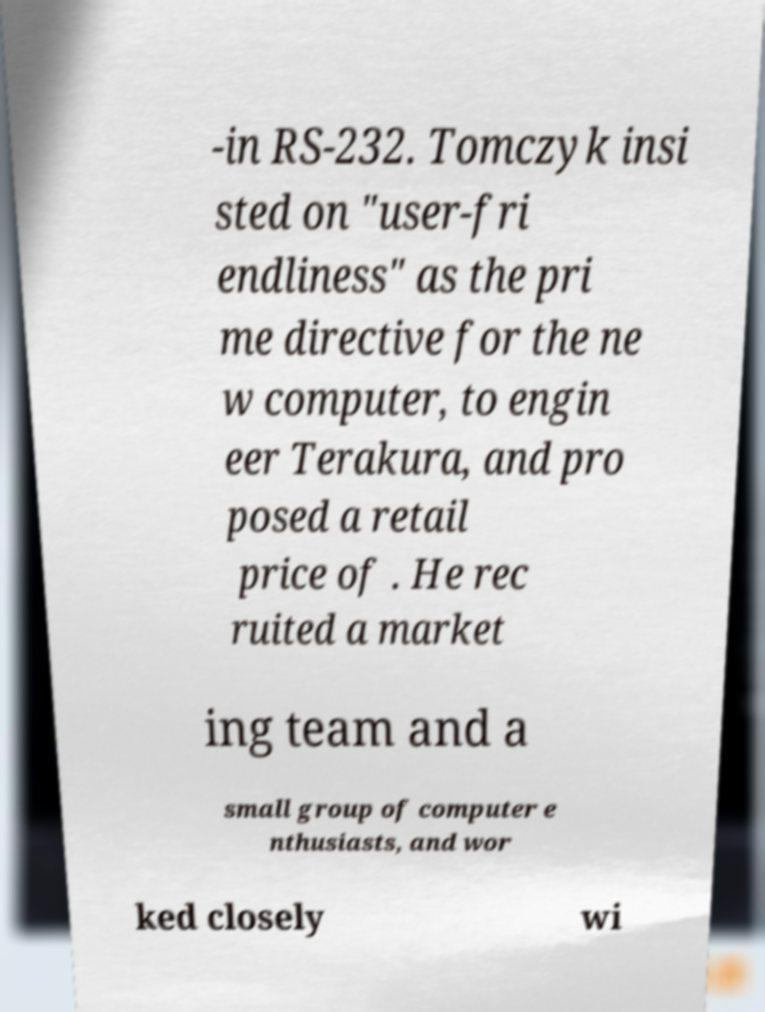Could you assist in decoding the text presented in this image and type it out clearly? -in RS-232. Tomczyk insi sted on "user-fri endliness" as the pri me directive for the ne w computer, to engin eer Terakura, and pro posed a retail price of . He rec ruited a market ing team and a small group of computer e nthusiasts, and wor ked closely wi 